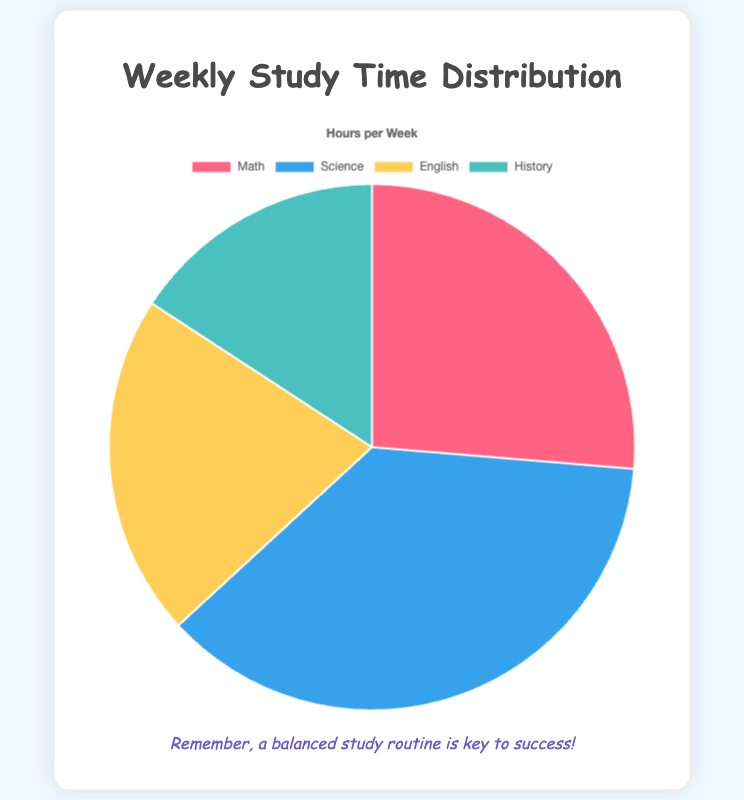What percentage of the weekly study time is dedicated to Math? There are 5 hours spent on Math out of a total of 19 hours. To find the percentage, divide the hours spent on Math by the total hours and multiply by 100: (5/19) * 100 ≈ 26.32%.
Answer: 26.32% Which subject has the least study time per week? Referring to the data, History has the fewest hours, with just 3 hours per week.
Answer: History What is the total weekly study time for all subjects combined? Add all the hours for each subject: 5 (Math) + 7 (Science) + 4 (English) + 3 (History) = 19 hours.
Answer: 19 hours How much more time is spent on Science compared to English? The time spent on Science is 7 hours, while for English it is 4 hours. The difference is 7 - 4 = 3 hours.
Answer: 3 hours What fraction of the weekly study time is spent on History compared to the total study time? History has 3 hours out of a total of 19 hours. The fraction is 3/19.
Answer: 3/19 What is the average weekly study time per subject? Sum all the study hours (19 hours) and divide by the number of subjects (4): 19 / 4 = 4.75 hours.
Answer: 4.75 hours Which subject has a greater share of study time per week, Math or English, and by how much? Math has 5 hours and English has 4 hours. Math has 1 hour more than English: 5 - 4 = 1 hour.
Answer: Math by 1 hour What is the ratio of study time between Science and History? Science has 7 hours and History has 3 hours. The ratio of Science to History is 7:3.
Answer: 7:3 Which slice of the pie chart is represented by the color blue? The visual representation in the chart shows that Science is represented by the color blue.
Answer: Science 